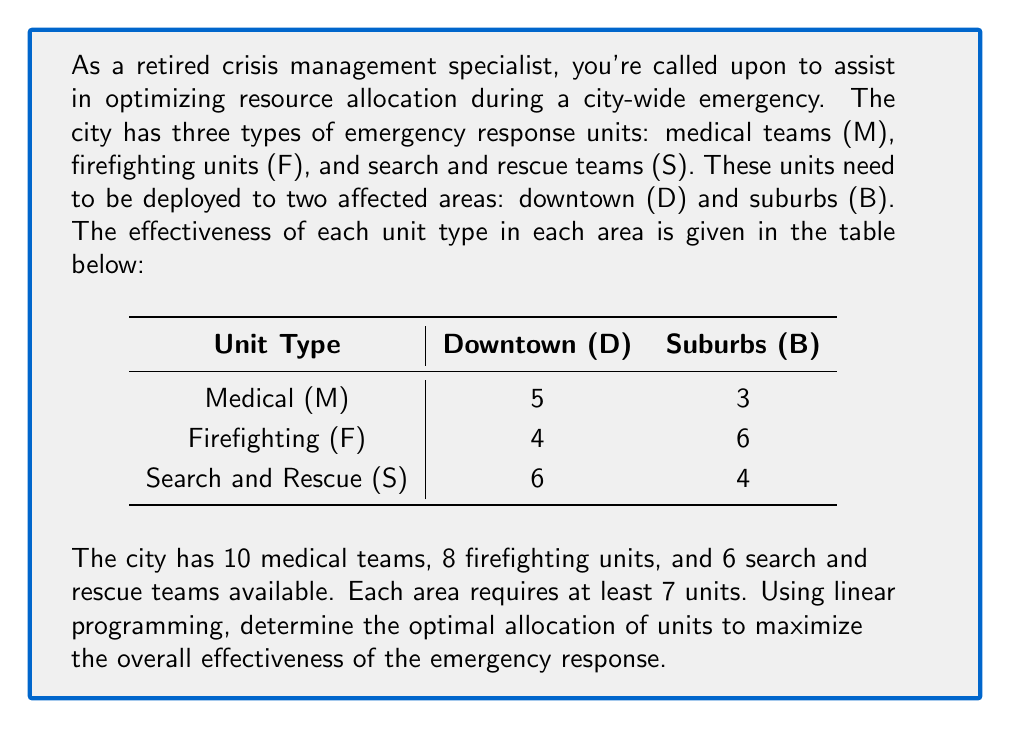Provide a solution to this math problem. Let's approach this step-by-step using linear programming:

1) Define variables:
   Let $x_1, x_2, x_3$ be the number of M, F, S units sent to downtown (D)
   Let $y_1, y_2, y_3$ be the number of M, F, S units sent to suburbs (B)

2) Objective function:
   Maximize $Z = 5x_1 + 4x_2 + 6x_3 + 3y_1 + 6y_2 + 4y_3$

3) Constraints:
   a) Resource limitations:
      $x_1 + y_1 \leq 10$ (Medical teams)
      $x_2 + y_2 \leq 8$  (Firefighting units)
      $x_3 + y_3 \leq 6$  (Search and Rescue teams)
   
   b) Minimum units per area:
      $x_1 + x_2 + x_3 \geq 7$ (Downtown)
      $y_1 + y_2 + y_3 \geq 7$ (Suburbs)
   
   c) Non-negativity:
      $x_1, x_2, x_3, y_1, y_2, y_3 \geq 0$

4) Solve using the simplex method or linear programming software.

5) The optimal solution is:
   $x_1 = 4, x_2 = 0, x_3 = 3, y_1 = 6, y_2 = 8, y_3 = 3$

6) This allocation gives a maximum effectiveness of:
   $Z = 5(4) + 4(0) + 6(3) + 3(6) + 6(8) + 4(3) = 98$

Therefore, the optimal allocation is:
- Downtown (D): 4 medical teams, 0 firefighting units, 3 search and rescue teams
- Suburbs (B): 6 medical teams, 8 firefighting units, 3 search and rescue teams
Answer: D: 4M, 0F, 3S; B: 6M, 8F, 3S; Max effectiveness: 98 